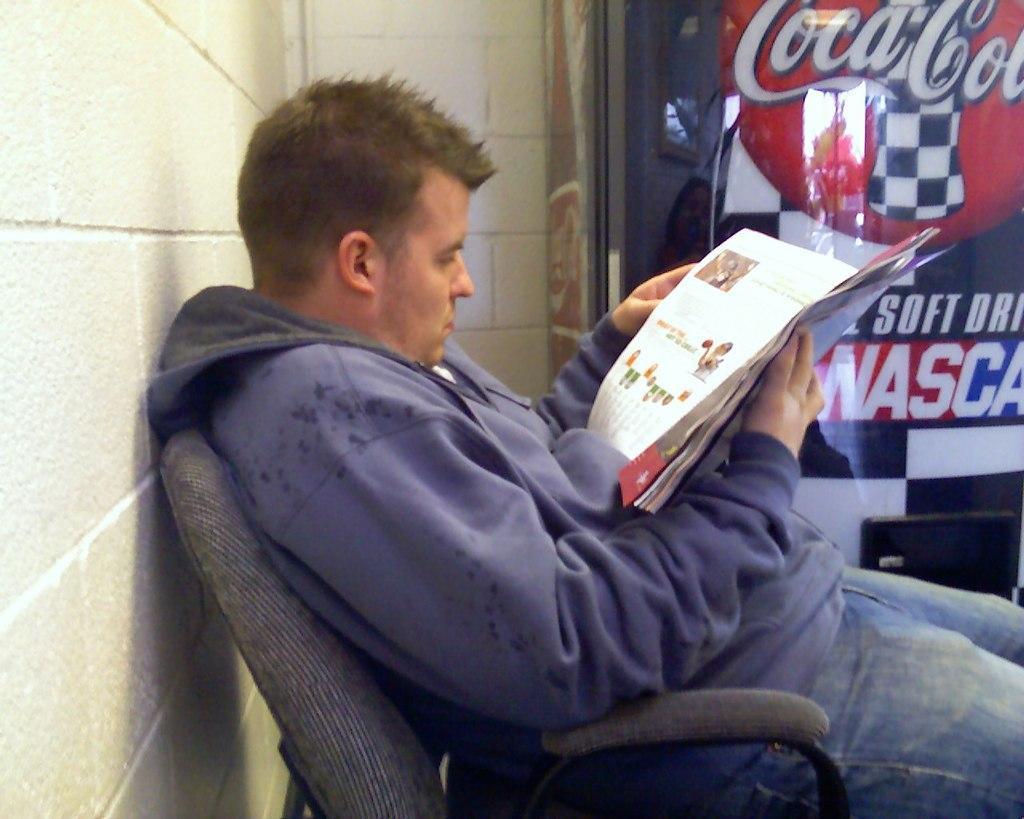Can you describe this image briefly? In the picture I can see a man sitting on a chair and looks like he is reading a newspaper. He is wearing the jacket and pant. There is a wall on the left side. I can see the glass door on the top right side. 